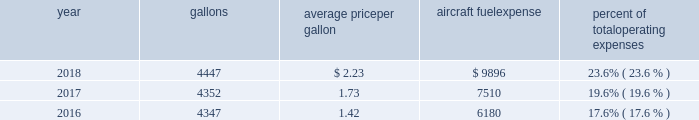The table shows annual aircraft fuel consumption and costs , including taxes , for our mainline and regional operations for 2018 , 2017 and 2016 ( gallons and aircraft fuel expense in millions ) .
Year gallons average price per gallon aircraft fuel expense percent of total operating expenses .
As of december 31 , 2018 , we did not have any fuel hedging contracts outstanding to hedge our fuel consumption .
As such , and assuming we do not enter into any future transactions to hedge our fuel consumption , we will continue to be fully exposed to fluctuations in fuel prices .
Our current policy is not to enter into transactions to hedge our fuel consumption , although we review that policy from time to time based on market conditions and other factors .
Fuel prices have fluctuated substantially over the past several years .
We cannot predict the future availability , price volatility or cost of aircraft fuel .
Natural disasters ( including hurricanes or similar events in the u.s .
Southeast and on the gulf coast where a significant portion of domestic refining capacity is located ) , political disruptions or wars involving oil-producing countries , economic sanctions imposed against oil-producing countries or specific industry participants , changes in fuel-related governmental policy , the strength of the u.s .
Dollar against foreign currencies , changes in the cost to transport or store petroleum products , changes in access to petroleum product pipelines and terminals , speculation in the energy futures markets , changes in aircraft fuel production capacity , environmental concerns and other unpredictable events may result in fuel supply shortages , distribution challenges , additional fuel price volatility and cost increases in the future .
See part i , item 1a .
Risk factors 2013 201cour business is very dependent on the price and availability of aircraft fuel .
Continued periods of high volatility in fuel costs , increased fuel prices or significant disruptions in the supply of aircraft fuel could have a significant negative impact on our operating results and liquidity . 201d seasonality and other factors due to the greater demand for air travel during the summer months , revenues in the airline industry in the second and third quarters of the year tend to be greater than revenues in the first and fourth quarters of the year .
General economic conditions , fears of terrorism or war , fare initiatives , fluctuations in fuel prices , labor actions , weather , natural disasters , outbreaks of disease and other factors could impact this seasonal pattern .
Therefore , our quarterly results of operations are not necessarily indicative of operating results for the entire year , and historical operating results in a quarterly or annual period are not necessarily indicative of future operating results .
Domestic and global regulatory landscape general airlines are subject to extensive domestic and international regulatory requirements .
Domestically , the dot and the federal aviation administration ( faa ) exercise significant regulatory authority over air carriers .
The dot , among other things , oversees domestic and international codeshare agreements , international route authorities , competition and consumer protection matters such as advertising , denied boarding compensation and baggage liability .
The antitrust division of the department of justice ( doj ) , along with the dot in certain instances , have jurisdiction over airline antitrust matters. .
What was the total aircraft fuel expense from 2016 to 2018 in millions? 
Computations: ((9896 + 7510) + 6180)
Answer: 23586.0. 